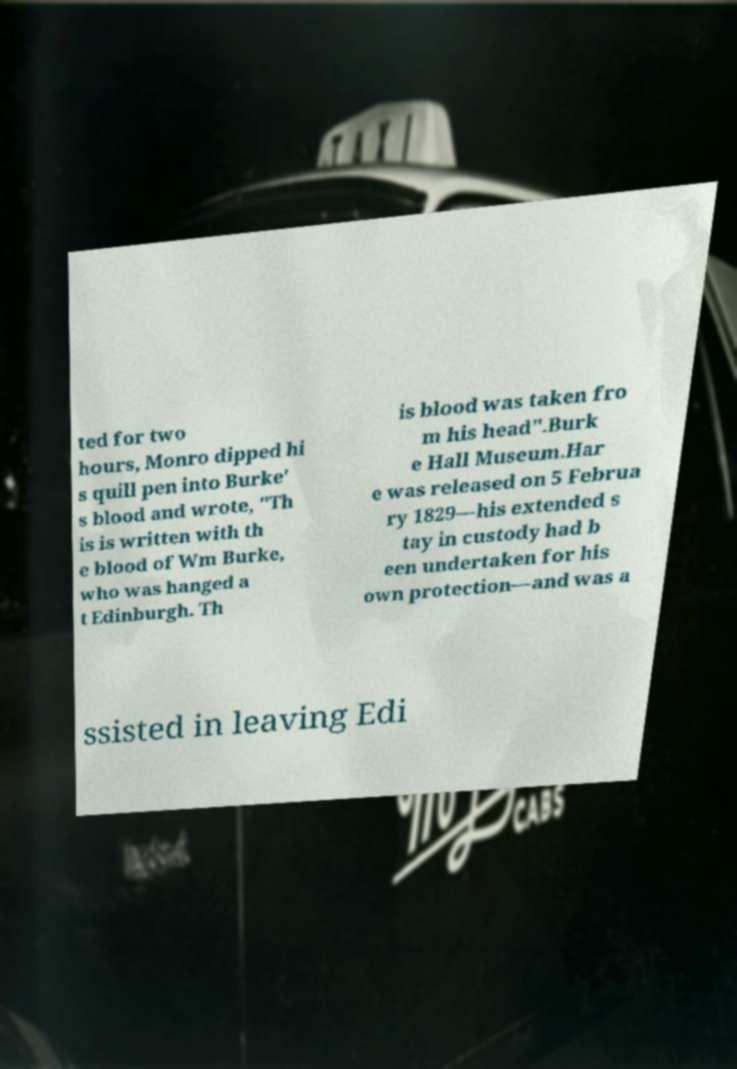Can you accurately transcribe the text from the provided image for me? ted for two hours, Monro dipped hi s quill pen into Burke' s blood and wrote, "Th is is written with th e blood of Wm Burke, who was hanged a t Edinburgh. Th is blood was taken fro m his head".Burk e Hall Museum.Har e was released on 5 Februa ry 1829—his extended s tay in custody had b een undertaken for his own protection—and was a ssisted in leaving Edi 